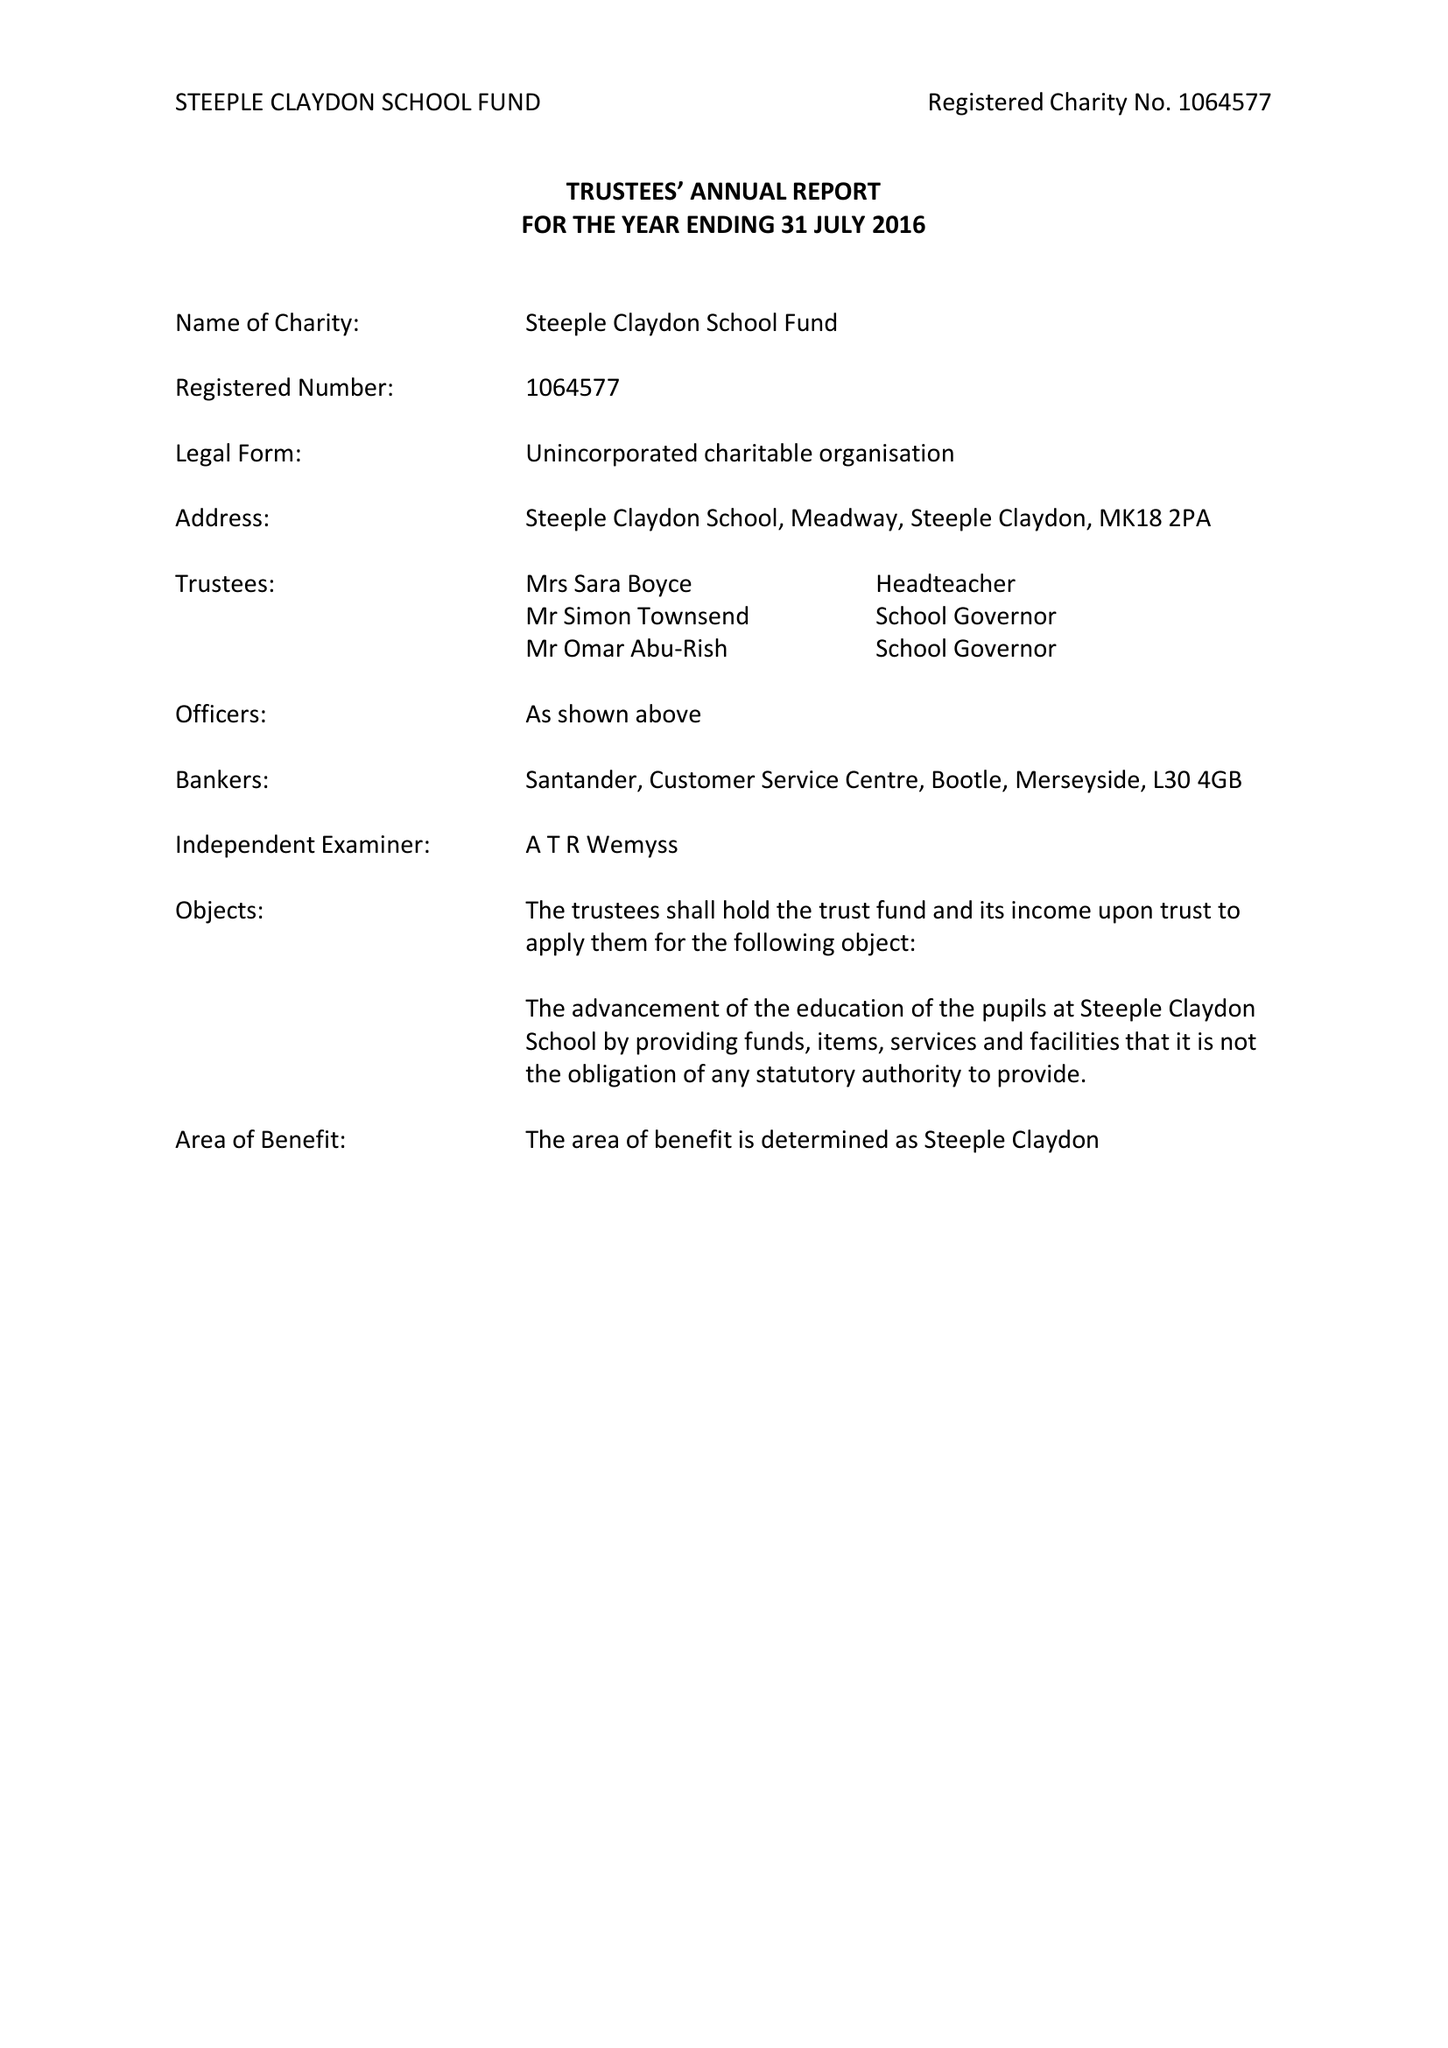What is the value for the address__postcode?
Answer the question using a single word or phrase. MK18 2PA 